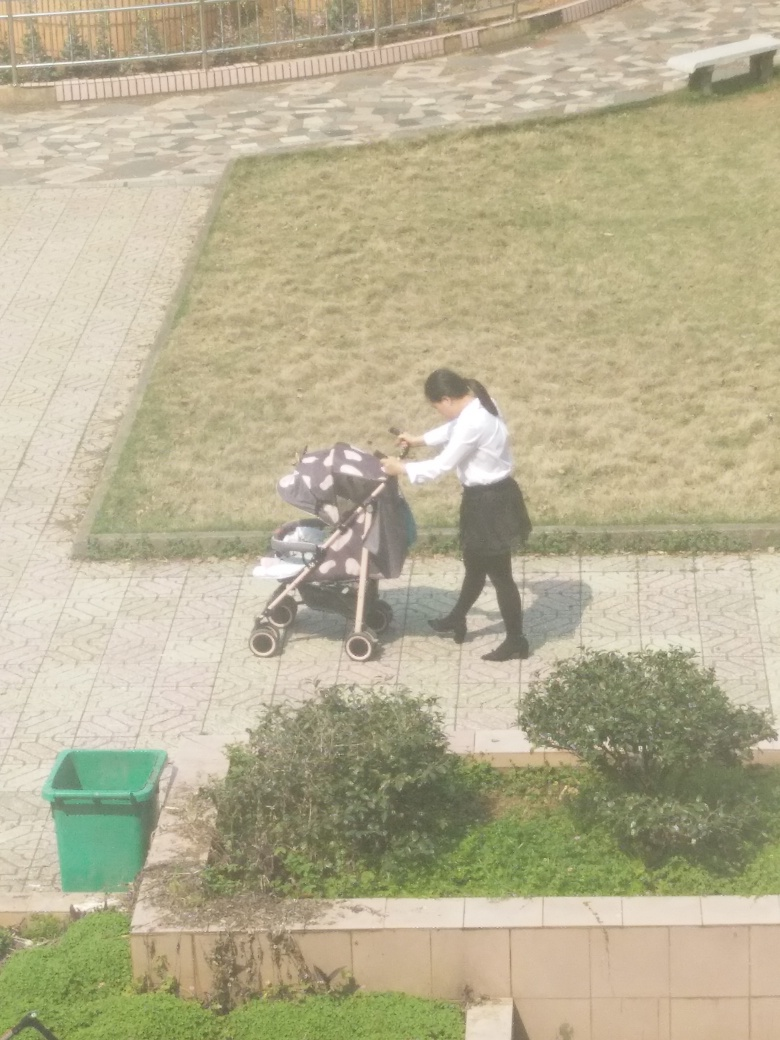Why does the background appear slightly blurry? The background of the image shows a degree of blur which is likely due to the depth of field effect. This occurs when the camera's focus is set on a close subject, such as the person, causing objects at different distances, like the background, to appear out of focus. It’s a common technique used in photography to draw the viewer’s attention to the main subject. 